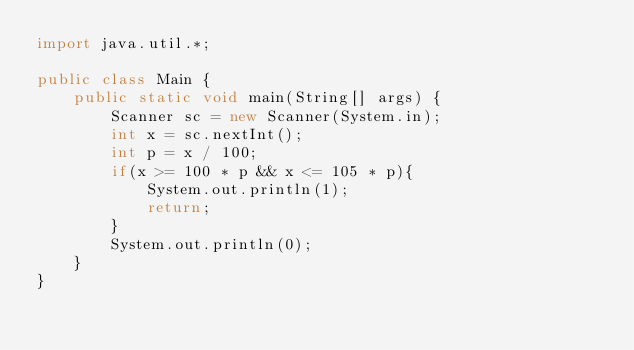Convert code to text. <code><loc_0><loc_0><loc_500><loc_500><_Java_>import java.util.*;

public class Main {
    public static void main(String[] args) {
        Scanner sc = new Scanner(System.in);
        int x = sc.nextInt();
        int p = x / 100;
        if(x >= 100 * p && x <= 105 * p){
            System.out.println(1);
            return;
        }
        System.out.println(0);
    }
}</code> 